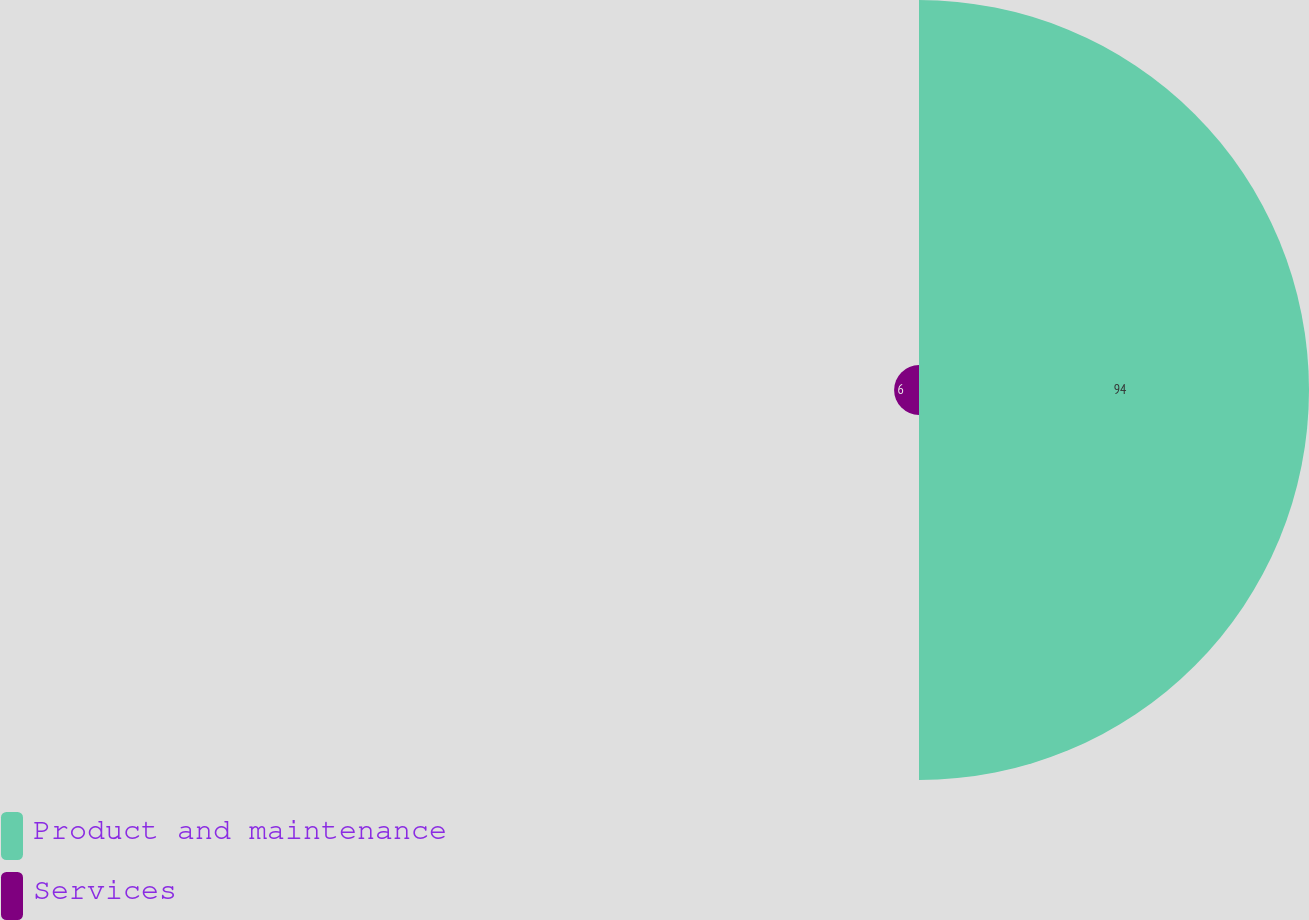Convert chart. <chart><loc_0><loc_0><loc_500><loc_500><pie_chart><fcel>Product and maintenance<fcel>Services<nl><fcel>94.0%<fcel>6.0%<nl></chart> 